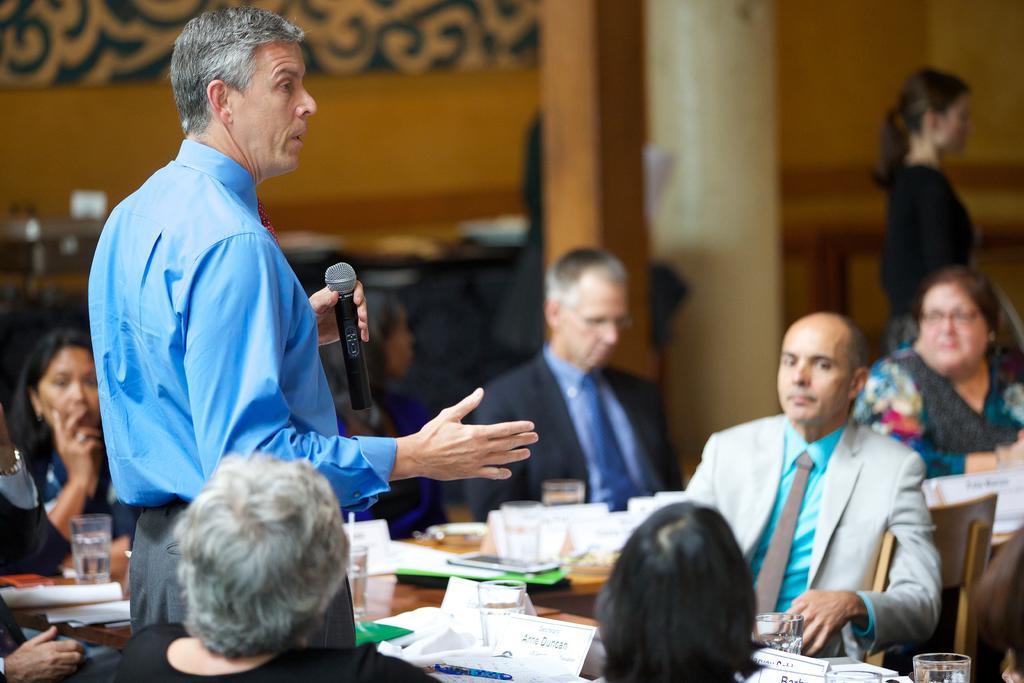How would you summarize this image in a sentence or two? In this image I can see there are few persons sitting in front of the table and a person standing and holding a mike on the table I can see glass and paper and I can see the wall at the top. 